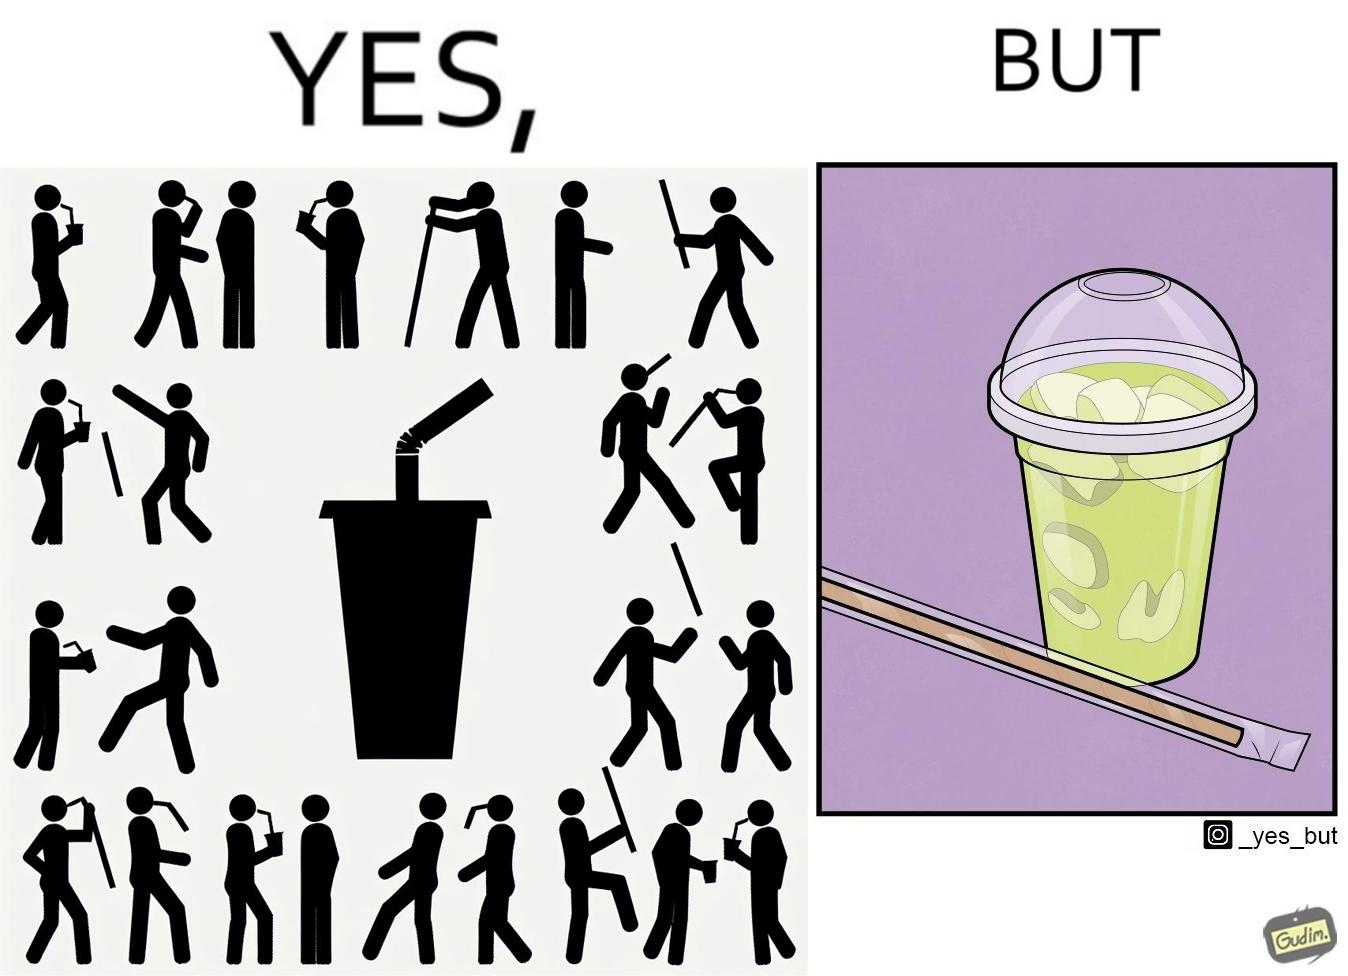Would you classify this image as satirical? Yes, this image is satirical. 